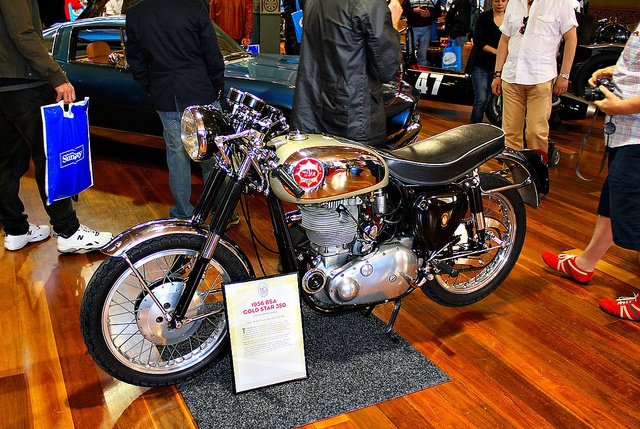Describe the objects in this image and their specific colors. I can see motorcycle in black, lightgray, gray, and darkgray tones, car in black, gray, blue, and navy tones, people in black, gray, and darkblue tones, people in black, lightgray, and olive tones, and people in black, blue, purple, and navy tones in this image. 